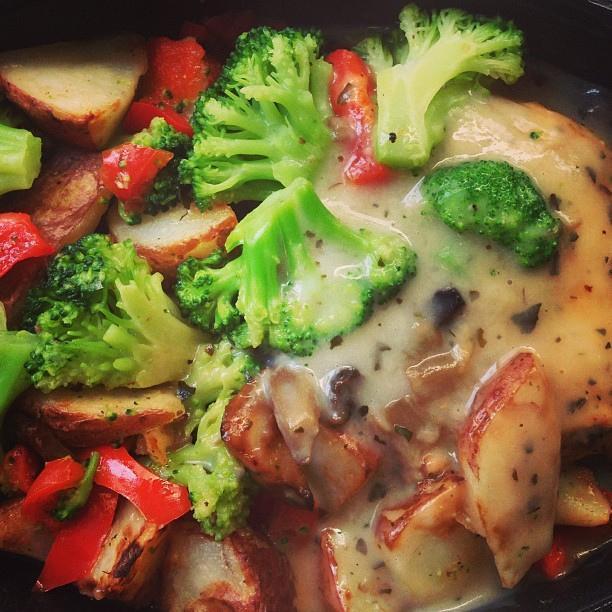How many broccolis are in the picture?
Give a very brief answer. 7. How many apples can be seen?
Give a very brief answer. 3. How many of the dogs have black spots?
Give a very brief answer. 0. 